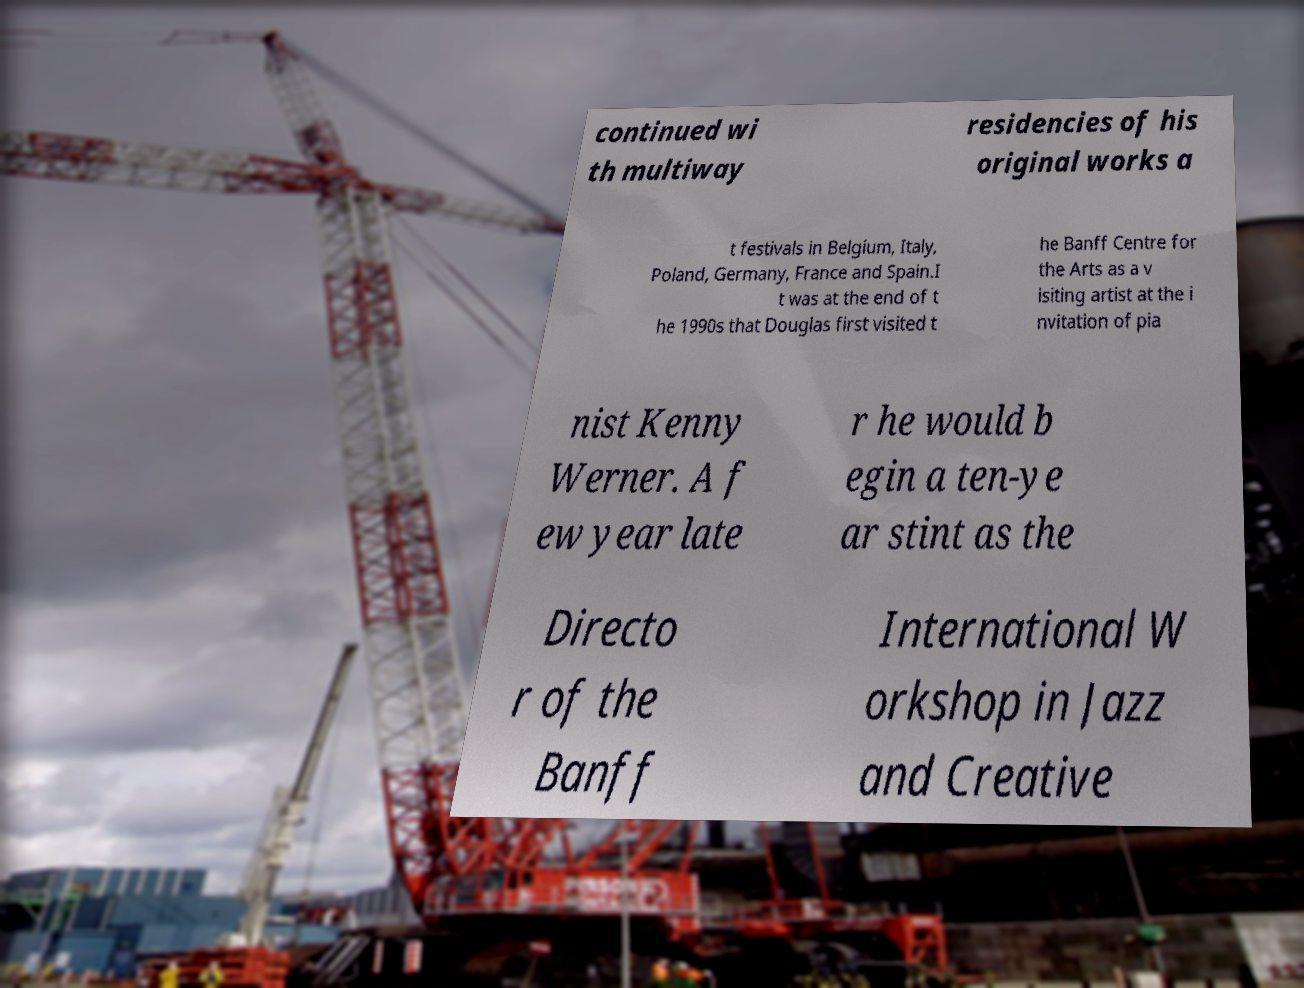There's text embedded in this image that I need extracted. Can you transcribe it verbatim? continued wi th multiway residencies of his original works a t festivals in Belgium, Italy, Poland, Germany, France and Spain.I t was at the end of t he 1990s that Douglas first visited t he Banff Centre for the Arts as a v isiting artist at the i nvitation of pia nist Kenny Werner. A f ew year late r he would b egin a ten-ye ar stint as the Directo r of the Banff International W orkshop in Jazz and Creative 